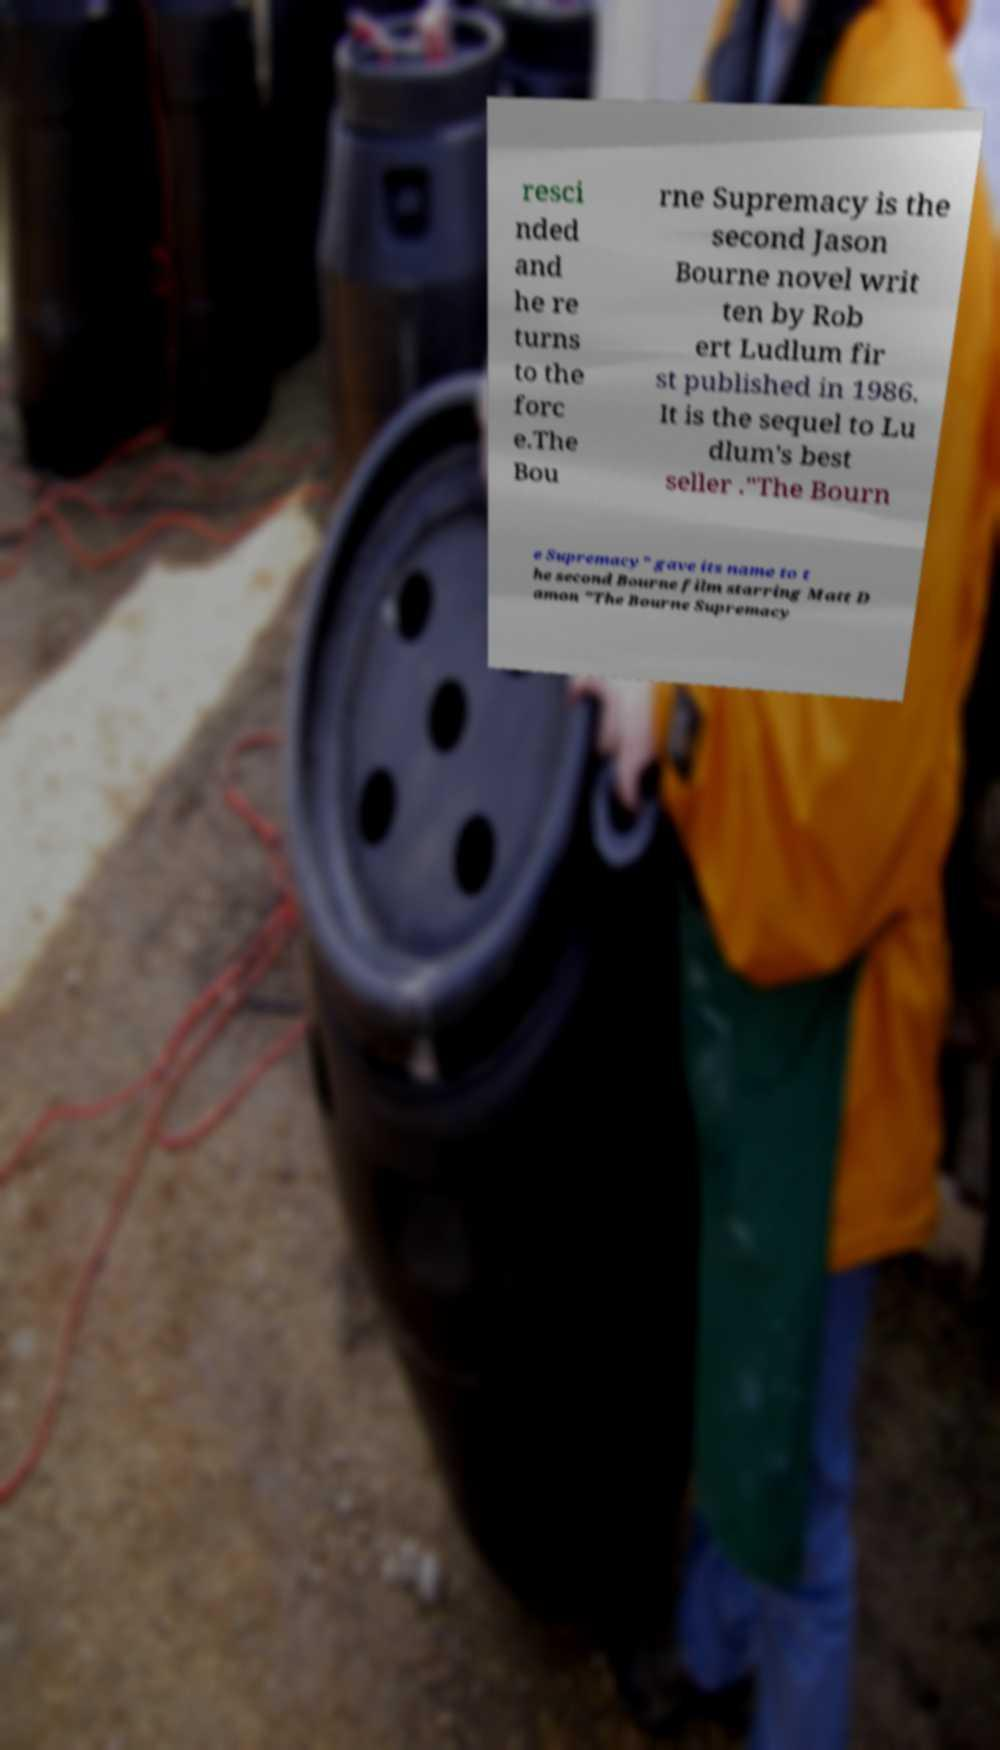Can you accurately transcribe the text from the provided image for me? resci nded and he re turns to the forc e.The Bou rne Supremacy is the second Jason Bourne novel writ ten by Rob ert Ludlum fir st published in 1986. It is the sequel to Lu dlum's best seller ."The Bourn e Supremacy" gave its name to t he second Bourne film starring Matt D amon "The Bourne Supremacy 